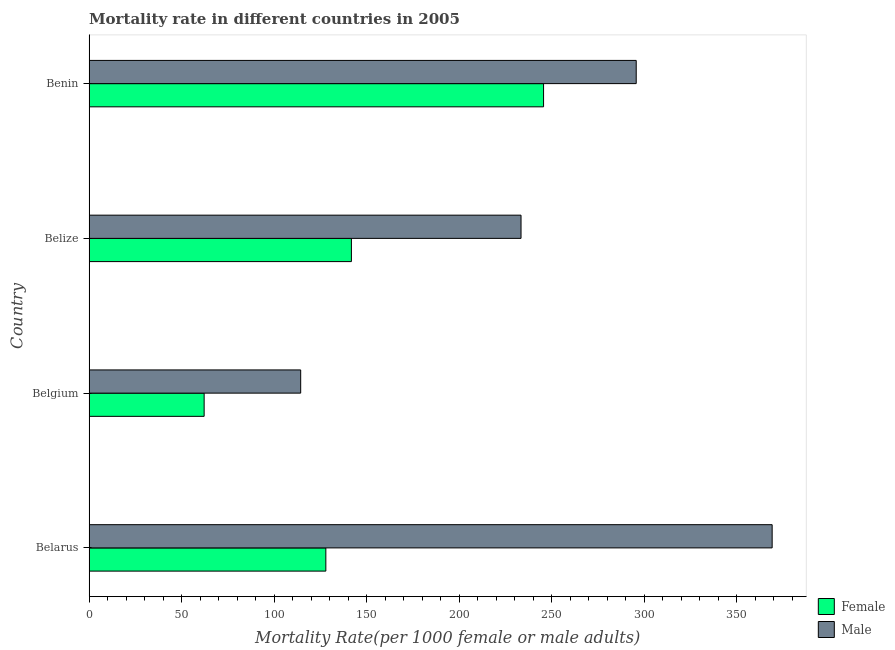Are the number of bars per tick equal to the number of legend labels?
Give a very brief answer. Yes. What is the label of the 2nd group of bars from the top?
Your answer should be compact. Belize. What is the female mortality rate in Belgium?
Keep it short and to the point. 62.2. Across all countries, what is the maximum male mortality rate?
Give a very brief answer. 369.26. Across all countries, what is the minimum male mortality rate?
Your response must be concise. 114.39. In which country was the female mortality rate maximum?
Offer a terse response. Benin. What is the total male mortality rate in the graph?
Give a very brief answer. 1012.92. What is the difference between the male mortality rate in Belarus and that in Belgium?
Your answer should be compact. 254.87. What is the difference between the female mortality rate in Belarus and the male mortality rate in Belize?
Provide a succinct answer. -105.52. What is the average male mortality rate per country?
Ensure brevity in your answer.  253.23. What is the difference between the female mortality rate and male mortality rate in Belgium?
Give a very brief answer. -52.19. What is the ratio of the male mortality rate in Belarus to that in Belgium?
Provide a short and direct response. 3.23. Is the female mortality rate in Belarus less than that in Belize?
Give a very brief answer. Yes. What is the difference between the highest and the second highest female mortality rate?
Keep it short and to the point. 103.88. What is the difference between the highest and the lowest male mortality rate?
Your response must be concise. 254.87. How many bars are there?
Provide a short and direct response. 8. What is the difference between two consecutive major ticks on the X-axis?
Provide a succinct answer. 50. Does the graph contain grids?
Provide a succinct answer. No. How many legend labels are there?
Ensure brevity in your answer.  2. What is the title of the graph?
Your answer should be very brief. Mortality rate in different countries in 2005. What is the label or title of the X-axis?
Make the answer very short. Mortality Rate(per 1000 female or male adults). What is the label or title of the Y-axis?
Provide a short and direct response. Country. What is the Mortality Rate(per 1000 female or male adults) in Female in Belarus?
Ensure brevity in your answer.  127.98. What is the Mortality Rate(per 1000 female or male adults) in Male in Belarus?
Provide a short and direct response. 369.26. What is the Mortality Rate(per 1000 female or male adults) in Female in Belgium?
Give a very brief answer. 62.2. What is the Mortality Rate(per 1000 female or male adults) in Male in Belgium?
Offer a terse response. 114.39. What is the Mortality Rate(per 1000 female or male adults) of Female in Belize?
Offer a terse response. 141.8. What is the Mortality Rate(per 1000 female or male adults) in Male in Belize?
Keep it short and to the point. 233.5. What is the Mortality Rate(per 1000 female or male adults) in Female in Benin?
Make the answer very short. 245.68. What is the Mortality Rate(per 1000 female or male adults) of Male in Benin?
Provide a short and direct response. 295.77. Across all countries, what is the maximum Mortality Rate(per 1000 female or male adults) of Female?
Offer a very short reply. 245.68. Across all countries, what is the maximum Mortality Rate(per 1000 female or male adults) in Male?
Give a very brief answer. 369.26. Across all countries, what is the minimum Mortality Rate(per 1000 female or male adults) in Female?
Make the answer very short. 62.2. Across all countries, what is the minimum Mortality Rate(per 1000 female or male adults) in Male?
Provide a succinct answer. 114.39. What is the total Mortality Rate(per 1000 female or male adults) of Female in the graph?
Provide a succinct answer. 577.66. What is the total Mortality Rate(per 1000 female or male adults) in Male in the graph?
Offer a terse response. 1012.92. What is the difference between the Mortality Rate(per 1000 female or male adults) of Female in Belarus and that in Belgium?
Make the answer very short. 65.79. What is the difference between the Mortality Rate(per 1000 female or male adults) in Male in Belarus and that in Belgium?
Provide a succinct answer. 254.87. What is the difference between the Mortality Rate(per 1000 female or male adults) of Female in Belarus and that in Belize?
Give a very brief answer. -13.82. What is the difference between the Mortality Rate(per 1000 female or male adults) of Male in Belarus and that in Belize?
Make the answer very short. 135.75. What is the difference between the Mortality Rate(per 1000 female or male adults) in Female in Belarus and that in Benin?
Your response must be concise. -117.7. What is the difference between the Mortality Rate(per 1000 female or male adults) of Male in Belarus and that in Benin?
Your answer should be compact. 73.49. What is the difference between the Mortality Rate(per 1000 female or male adults) of Female in Belgium and that in Belize?
Make the answer very short. -79.61. What is the difference between the Mortality Rate(per 1000 female or male adults) in Male in Belgium and that in Belize?
Make the answer very short. -119.11. What is the difference between the Mortality Rate(per 1000 female or male adults) of Female in Belgium and that in Benin?
Provide a short and direct response. -183.49. What is the difference between the Mortality Rate(per 1000 female or male adults) of Male in Belgium and that in Benin?
Your response must be concise. -181.38. What is the difference between the Mortality Rate(per 1000 female or male adults) of Female in Belize and that in Benin?
Offer a terse response. -103.88. What is the difference between the Mortality Rate(per 1000 female or male adults) in Male in Belize and that in Benin?
Offer a terse response. -62.27. What is the difference between the Mortality Rate(per 1000 female or male adults) of Female in Belarus and the Mortality Rate(per 1000 female or male adults) of Male in Belgium?
Provide a short and direct response. 13.6. What is the difference between the Mortality Rate(per 1000 female or male adults) in Female in Belarus and the Mortality Rate(per 1000 female or male adults) in Male in Belize?
Your response must be concise. -105.52. What is the difference between the Mortality Rate(per 1000 female or male adults) in Female in Belarus and the Mortality Rate(per 1000 female or male adults) in Male in Benin?
Provide a succinct answer. -167.79. What is the difference between the Mortality Rate(per 1000 female or male adults) of Female in Belgium and the Mortality Rate(per 1000 female or male adults) of Male in Belize?
Ensure brevity in your answer.  -171.31. What is the difference between the Mortality Rate(per 1000 female or male adults) of Female in Belgium and the Mortality Rate(per 1000 female or male adults) of Male in Benin?
Give a very brief answer. -233.57. What is the difference between the Mortality Rate(per 1000 female or male adults) of Female in Belize and the Mortality Rate(per 1000 female or male adults) of Male in Benin?
Your answer should be very brief. -153.97. What is the average Mortality Rate(per 1000 female or male adults) in Female per country?
Make the answer very short. 144.42. What is the average Mortality Rate(per 1000 female or male adults) of Male per country?
Keep it short and to the point. 253.23. What is the difference between the Mortality Rate(per 1000 female or male adults) in Female and Mortality Rate(per 1000 female or male adults) in Male in Belarus?
Your answer should be compact. -241.27. What is the difference between the Mortality Rate(per 1000 female or male adults) in Female and Mortality Rate(per 1000 female or male adults) in Male in Belgium?
Offer a very short reply. -52.19. What is the difference between the Mortality Rate(per 1000 female or male adults) in Female and Mortality Rate(per 1000 female or male adults) in Male in Belize?
Offer a very short reply. -91.7. What is the difference between the Mortality Rate(per 1000 female or male adults) in Female and Mortality Rate(per 1000 female or male adults) in Male in Benin?
Your answer should be very brief. -50.09. What is the ratio of the Mortality Rate(per 1000 female or male adults) in Female in Belarus to that in Belgium?
Ensure brevity in your answer.  2.06. What is the ratio of the Mortality Rate(per 1000 female or male adults) of Male in Belarus to that in Belgium?
Provide a short and direct response. 3.23. What is the ratio of the Mortality Rate(per 1000 female or male adults) in Female in Belarus to that in Belize?
Offer a terse response. 0.9. What is the ratio of the Mortality Rate(per 1000 female or male adults) of Male in Belarus to that in Belize?
Your answer should be very brief. 1.58. What is the ratio of the Mortality Rate(per 1000 female or male adults) of Female in Belarus to that in Benin?
Provide a succinct answer. 0.52. What is the ratio of the Mortality Rate(per 1000 female or male adults) in Male in Belarus to that in Benin?
Ensure brevity in your answer.  1.25. What is the ratio of the Mortality Rate(per 1000 female or male adults) in Female in Belgium to that in Belize?
Provide a short and direct response. 0.44. What is the ratio of the Mortality Rate(per 1000 female or male adults) of Male in Belgium to that in Belize?
Offer a very short reply. 0.49. What is the ratio of the Mortality Rate(per 1000 female or male adults) in Female in Belgium to that in Benin?
Your answer should be very brief. 0.25. What is the ratio of the Mortality Rate(per 1000 female or male adults) in Male in Belgium to that in Benin?
Keep it short and to the point. 0.39. What is the ratio of the Mortality Rate(per 1000 female or male adults) of Female in Belize to that in Benin?
Ensure brevity in your answer.  0.58. What is the ratio of the Mortality Rate(per 1000 female or male adults) of Male in Belize to that in Benin?
Offer a very short reply. 0.79. What is the difference between the highest and the second highest Mortality Rate(per 1000 female or male adults) of Female?
Your response must be concise. 103.88. What is the difference between the highest and the second highest Mortality Rate(per 1000 female or male adults) in Male?
Offer a very short reply. 73.49. What is the difference between the highest and the lowest Mortality Rate(per 1000 female or male adults) in Female?
Give a very brief answer. 183.49. What is the difference between the highest and the lowest Mortality Rate(per 1000 female or male adults) of Male?
Your answer should be compact. 254.87. 